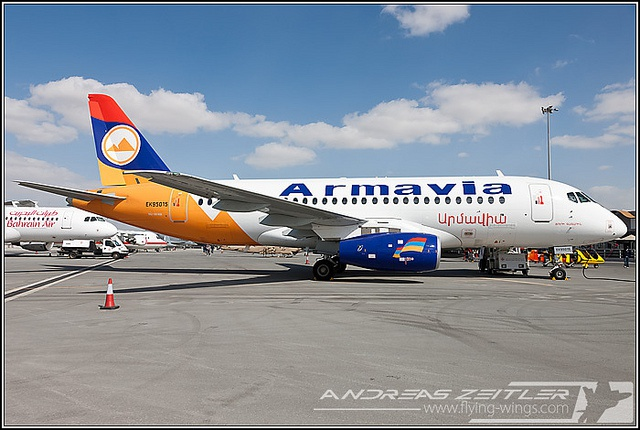Describe the objects in this image and their specific colors. I can see airplane in black, white, gray, and darkgray tones, airplane in black, white, darkgray, gray, and lightpink tones, truck in black, white, gray, and darkgray tones, and airplane in black, white, gray, and darkgray tones in this image. 